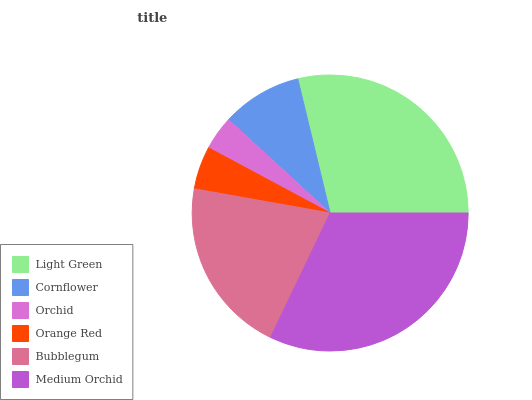Is Orchid the minimum?
Answer yes or no. Yes. Is Medium Orchid the maximum?
Answer yes or no. Yes. Is Cornflower the minimum?
Answer yes or no. No. Is Cornflower the maximum?
Answer yes or no. No. Is Light Green greater than Cornflower?
Answer yes or no. Yes. Is Cornflower less than Light Green?
Answer yes or no. Yes. Is Cornflower greater than Light Green?
Answer yes or no. No. Is Light Green less than Cornflower?
Answer yes or no. No. Is Bubblegum the high median?
Answer yes or no. Yes. Is Cornflower the low median?
Answer yes or no. Yes. Is Medium Orchid the high median?
Answer yes or no. No. Is Bubblegum the low median?
Answer yes or no. No. 